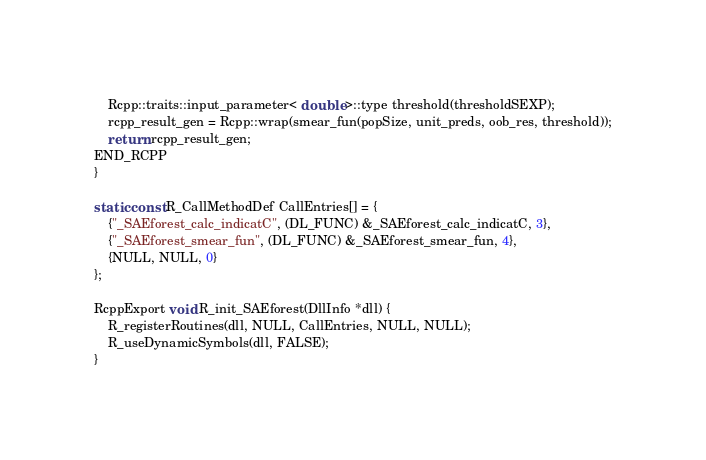Convert code to text. <code><loc_0><loc_0><loc_500><loc_500><_C++_>    Rcpp::traits::input_parameter< double >::type threshold(thresholdSEXP);
    rcpp_result_gen = Rcpp::wrap(smear_fun(popSize, unit_preds, oob_res, threshold));
    return rcpp_result_gen;
END_RCPP
}

static const R_CallMethodDef CallEntries[] = {
    {"_SAEforest_calc_indicatC", (DL_FUNC) &_SAEforest_calc_indicatC, 3},
    {"_SAEforest_smear_fun", (DL_FUNC) &_SAEforest_smear_fun, 4},
    {NULL, NULL, 0}
};

RcppExport void R_init_SAEforest(DllInfo *dll) {
    R_registerRoutines(dll, NULL, CallEntries, NULL, NULL);
    R_useDynamicSymbols(dll, FALSE);
}
</code> 